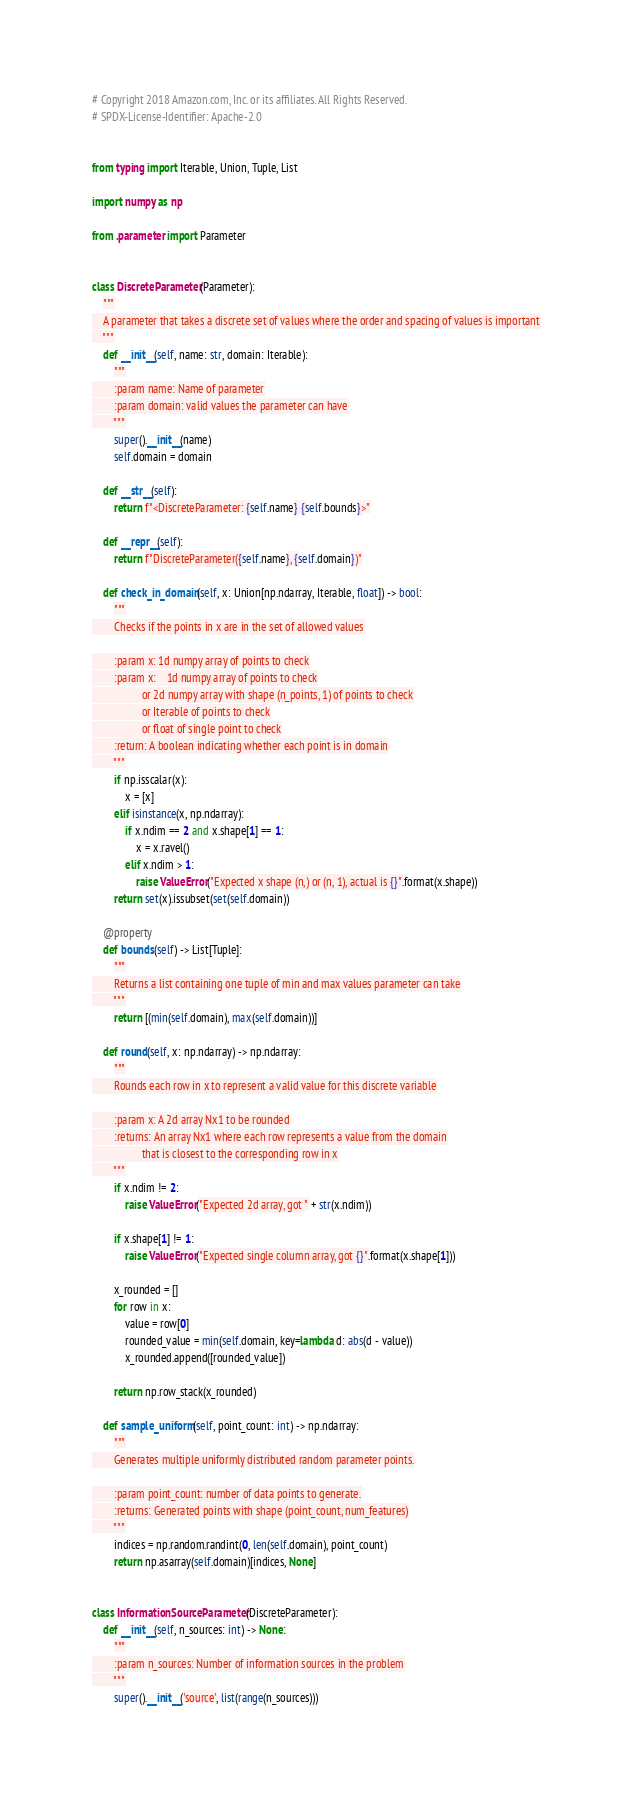Convert code to text. <code><loc_0><loc_0><loc_500><loc_500><_Python_># Copyright 2018 Amazon.com, Inc. or its affiliates. All Rights Reserved.
# SPDX-License-Identifier: Apache-2.0


from typing import Iterable, Union, Tuple, List

import numpy as np

from .parameter import Parameter


class DiscreteParameter(Parameter):
    """
    A parameter that takes a discrete set of values where the order and spacing of values is important
    """
    def __init__(self, name: str, domain: Iterable):
        """
        :param name: Name of parameter
        :param domain: valid values the parameter can have
        """
        super().__init__(name)
        self.domain = domain

    def __str__(self):
        return f"<DiscreteParameter: {self.name} {self.bounds}>"

    def __repr__(self):
        return f"DiscreteParameter({self.name}, {self.domain})"

    def check_in_domain(self, x: Union[np.ndarray, Iterable, float]) -> bool:
        """
        Checks if the points in x are in the set of allowed values

        :param x: 1d numpy array of points to check
        :param x:    1d numpy array of points to check
                  or 2d numpy array with shape (n_points, 1) of points to check
                  or Iterable of points to check
                  or float of single point to check
        :return: A boolean indicating whether each point is in domain
        """
        if np.isscalar(x):
            x = [x]
        elif isinstance(x, np.ndarray):
            if x.ndim == 2 and x.shape[1] == 1:
                x = x.ravel()
            elif x.ndim > 1:
                raise ValueError("Expected x shape (n,) or (n, 1), actual is {}".format(x.shape))
        return set(x).issubset(set(self.domain))

    @property
    def bounds(self) -> List[Tuple]:
        """
        Returns a list containing one tuple of min and max values parameter can take
        """
        return [(min(self.domain), max(self.domain))]

    def round(self, x: np.ndarray) -> np.ndarray:
        """
        Rounds each row in x to represent a valid value for this discrete variable

        :param x: A 2d array Nx1 to be rounded
        :returns: An array Nx1 where each row represents a value from the domain
                  that is closest to the corresponding row in x
        """
        if x.ndim != 2:
            raise ValueError("Expected 2d array, got " + str(x.ndim))

        if x.shape[1] != 1:
            raise ValueError("Expected single column array, got {}".format(x.shape[1]))

        x_rounded = []
        for row in x:
            value = row[0]
            rounded_value = min(self.domain, key=lambda d: abs(d - value))
            x_rounded.append([rounded_value])

        return np.row_stack(x_rounded)

    def sample_uniform(self, point_count: int) -> np.ndarray:
        """
        Generates multiple uniformly distributed random parameter points.

        :param point_count: number of data points to generate.
        :returns: Generated points with shape (point_count, num_features)
        """
        indices = np.random.randint(0, len(self.domain), point_count)
        return np.asarray(self.domain)[indices, None]


class InformationSourceParameter(DiscreteParameter):
    def __init__(self, n_sources: int) -> None:
        """
        :param n_sources: Number of information sources in the problem
        """
        super().__init__('source', list(range(n_sources)))
</code> 